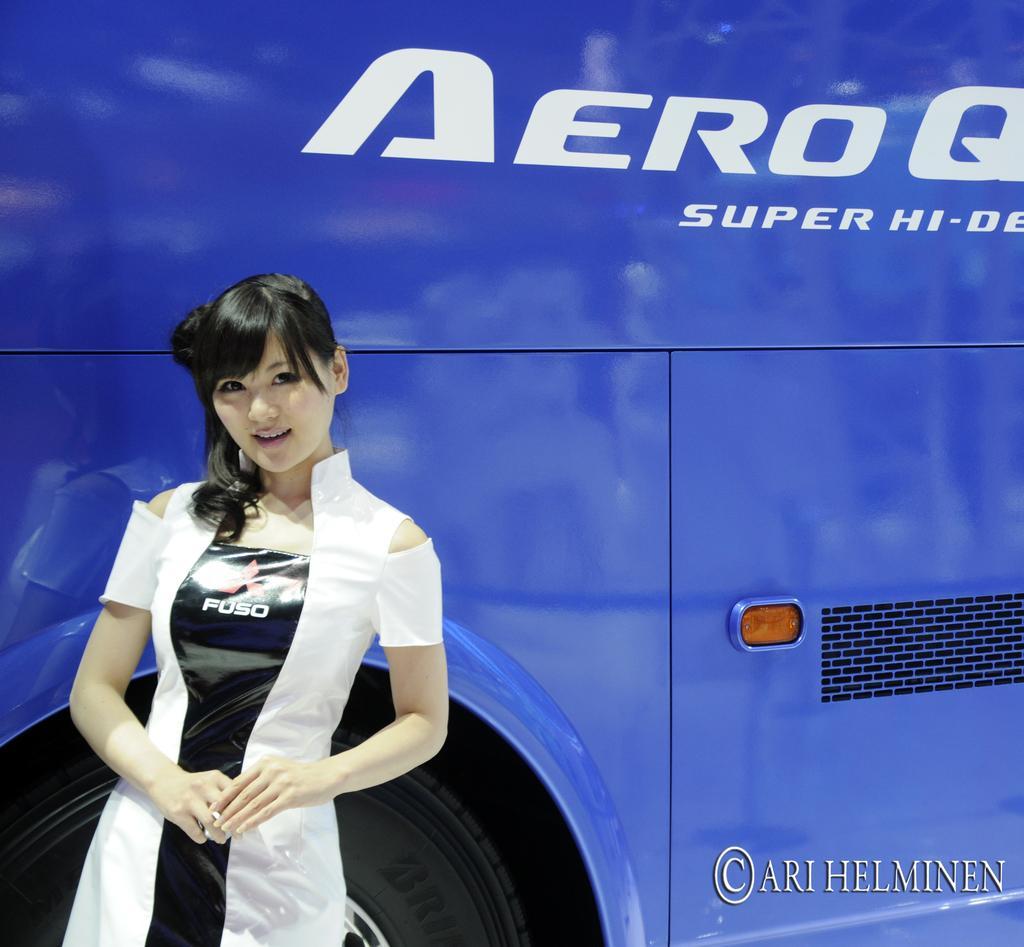Could you give a brief overview of what you see in this image? In this image I can see a woman is standing on the left side and I can see she is wearing a black and white colour dress. I can also see something is written on her dress and behind her I can see a blue colour vehicle. I can also see something is written on the vehicle and on the bottom right side of this image I can see a watermark. 